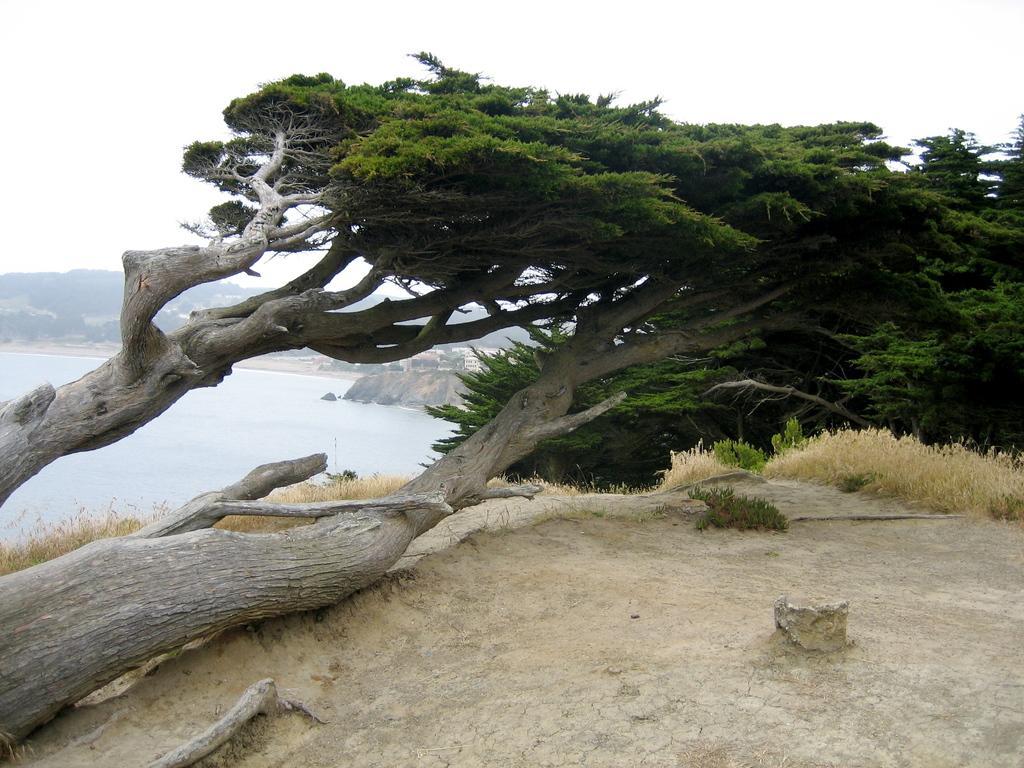How would you summarize this image in a sentence or two? In this image I can see a tree grows horizontally, a rock, some grass and other trees. I can see some buildings, river, and mountains behind the tree. At the top of the image I can see the sky.  